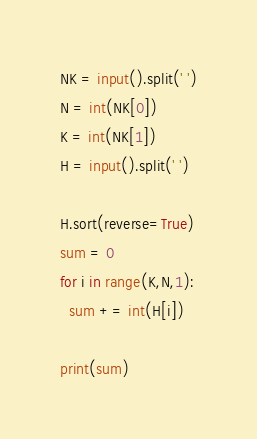Convert code to text. <code><loc_0><loc_0><loc_500><loc_500><_Python_>NK = input().split(' ')
N = int(NK[0])
K = int(NK[1])
H = input().split(' ')

H.sort(reverse=True)
sum = 0
for i in range(K,N,1):
  sum += int(H[i])
  
print(sum)</code> 